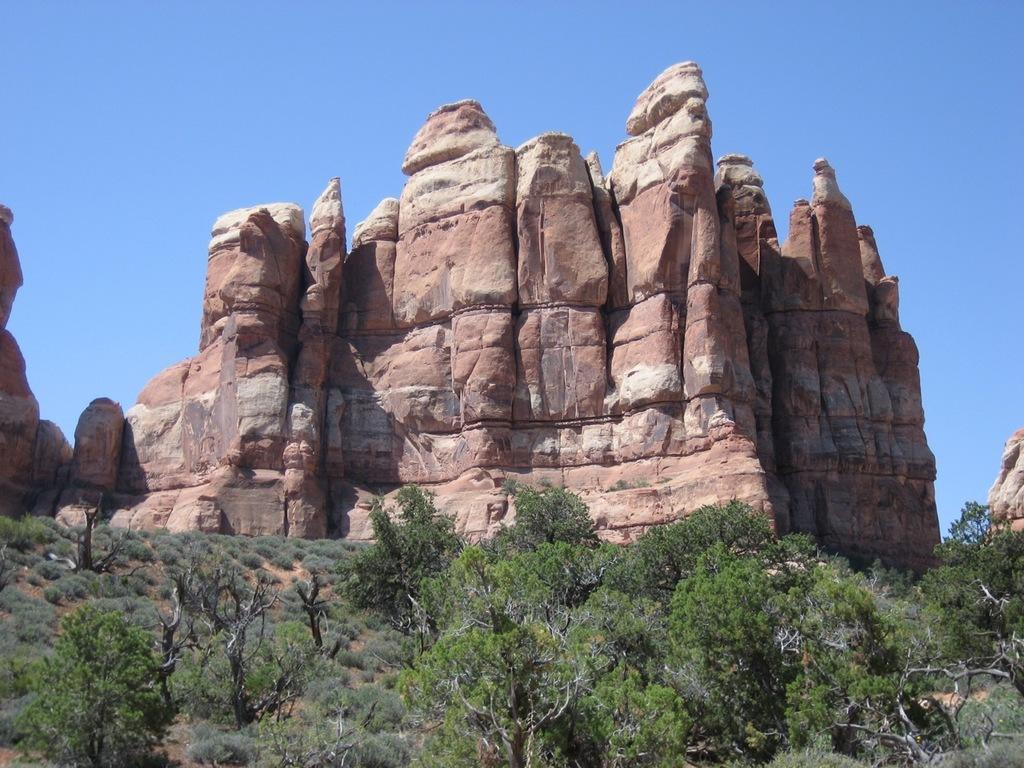Can you describe this image briefly? In the picture we can see some trees, plants on the surface and in the background, we can see huge rocks in the type of standing and behind it we can see a sky which is blue in color. 